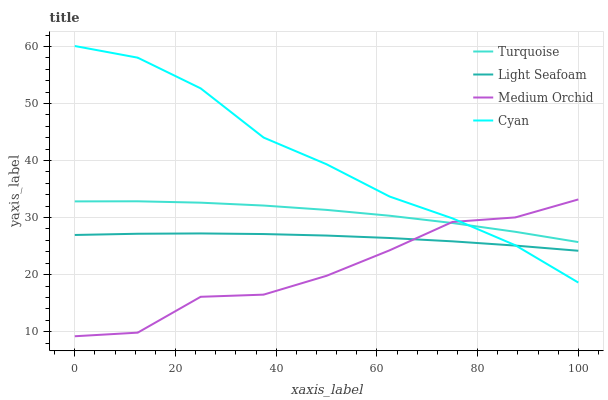Does Turquoise have the minimum area under the curve?
Answer yes or no. No. Does Turquoise have the maximum area under the curve?
Answer yes or no. No. Is Turquoise the smoothest?
Answer yes or no. No. Is Turquoise the roughest?
Answer yes or no. No. Does Light Seafoam have the lowest value?
Answer yes or no. No. Does Turquoise have the highest value?
Answer yes or no. No. Is Light Seafoam less than Turquoise?
Answer yes or no. Yes. Is Turquoise greater than Light Seafoam?
Answer yes or no. Yes. Does Light Seafoam intersect Turquoise?
Answer yes or no. No. 